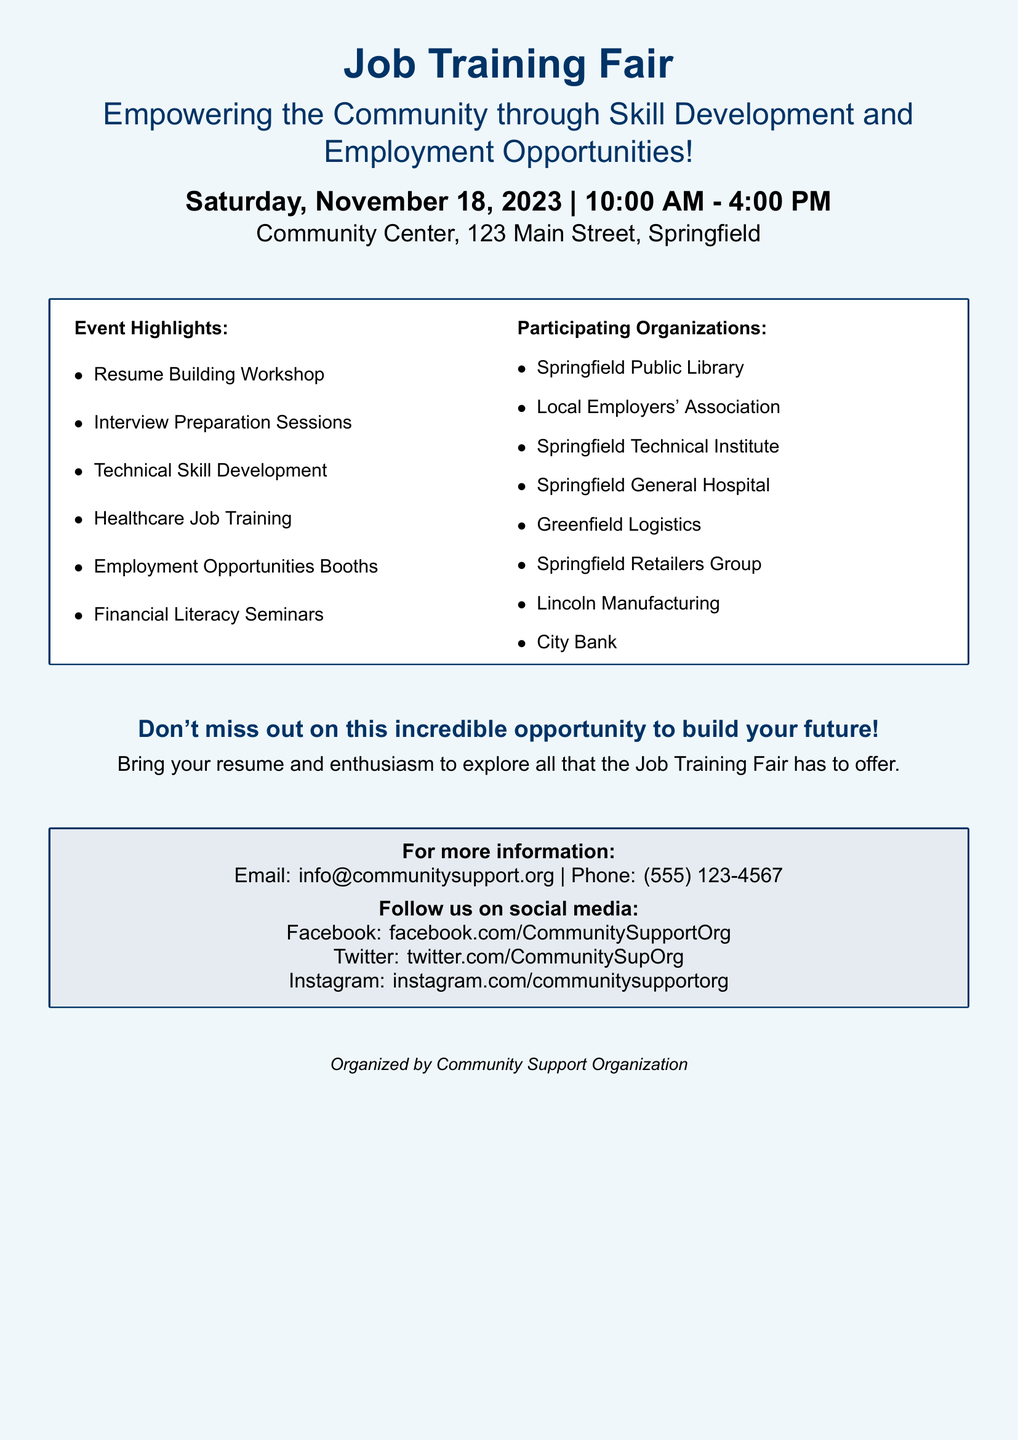What is the date of the Job Training Fair? The date is specifically mentioned in the document as Saturday, November 18, 2023.
Answer: Saturday, November 18, 2023 What time does the fair start? The starting time for the event is highlighted in the document as 10:00 AM.
Answer: 10:00 AM Where is the Job Training Fair taking place? The location for the fair is stated as Community Center, 123 Main Street, Springfield.
Answer: Community Center, 123 Main Street, Springfield What is one of the workshop topics offered at the fair? The event highlights list various workshops, one of which is Resume Building Workshop.
Answer: Resume Building Workshop Which organization is participating in the Job Training Fair? The document lists several participating organizations, one example is Springfield Technical Institute.
Answer: Springfield Technical Institute What should attendees bring to the Job Training Fair? The document advises attendees to bring their resume and enthusiasm.
Answer: Resume and enthusiasm How many employment opportunities booths will there be? While the document indicates there will be employment opportunities booths, the specific number is not mentioned.
Answer: Not specified What is the contact email for more information? The document provides a contact email, which is info@communitysupport.org.
Answer: info@communitysupport.org What social media platform is mentioned for following the organization? The document lists several social media platforms, including Facebook.
Answer: Facebook 